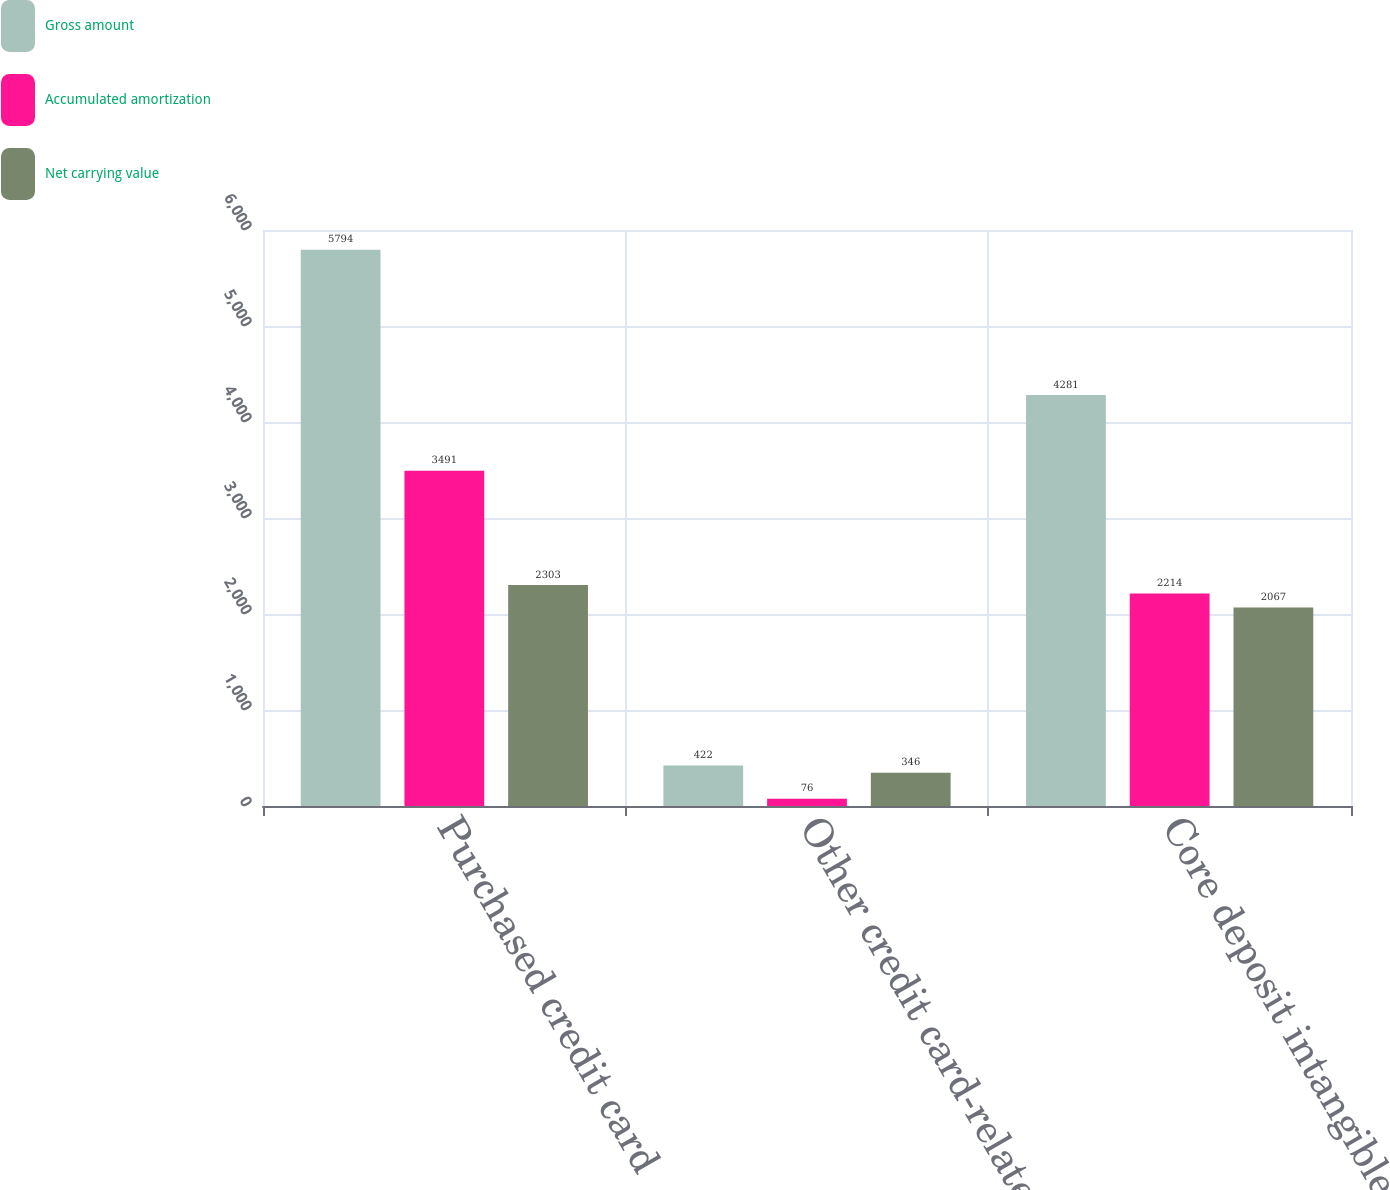Convert chart. <chart><loc_0><loc_0><loc_500><loc_500><stacked_bar_chart><ecel><fcel>Purchased credit card<fcel>Other credit card-related<fcel>Core deposit intangibles<nl><fcel>Gross amount<fcel>5794<fcel>422<fcel>4281<nl><fcel>Accumulated amortization<fcel>3491<fcel>76<fcel>2214<nl><fcel>Net carrying value<fcel>2303<fcel>346<fcel>2067<nl></chart> 